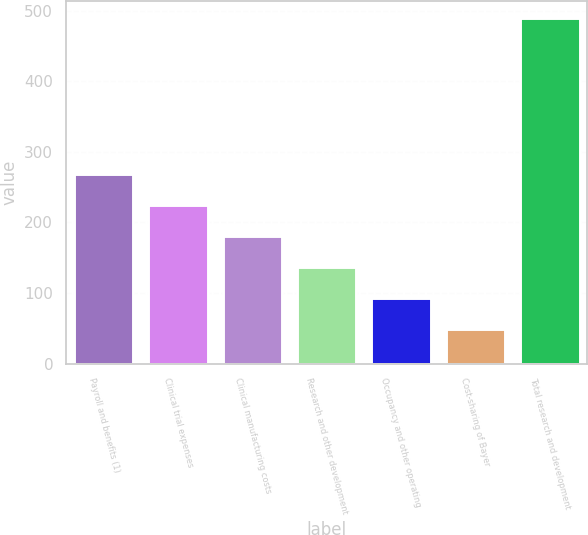Convert chart to OTSL. <chart><loc_0><loc_0><loc_500><loc_500><bar_chart><fcel>Payroll and benefits (1)<fcel>Clinical trial expenses<fcel>Clinical manufacturing costs<fcel>Research and other development<fcel>Occupancy and other operating<fcel>Cost-sharing of Bayer<fcel>Total research and development<nl><fcel>269.05<fcel>225.02<fcel>180.99<fcel>136.96<fcel>92.93<fcel>48.9<fcel>489.2<nl></chart> 